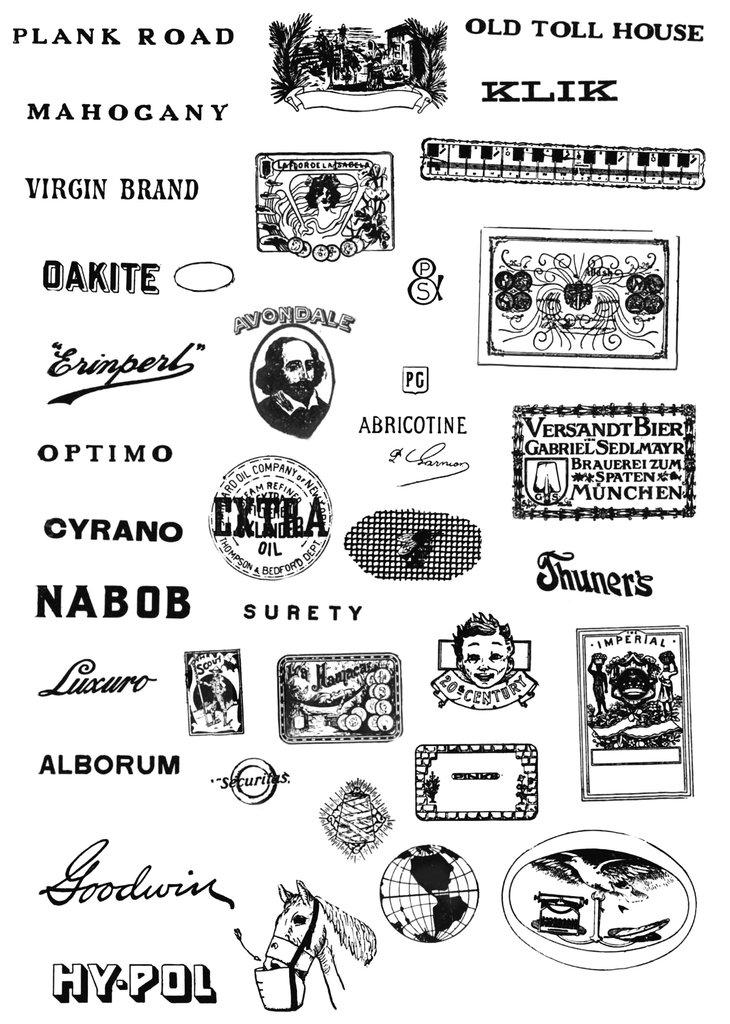What can be seen in the image? There are pictures in the image. What is featured on the pictures? There is writing on the pictures. How many stalks of celery are depicted in the image? There is no celery present in the image; it only features pictures with writing on them. 